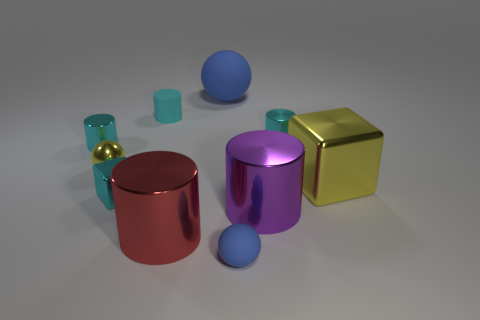There is a block that is to the left of the tiny rubber ball; is its color the same as the small shiny sphere?
Ensure brevity in your answer.  No. How many objects are either big objects or big shiny cylinders?
Provide a succinct answer. 4. Does the yellow metallic object that is right of the red cylinder have the same size as the tiny cyan matte cylinder?
Provide a short and direct response. No. What is the size of the cyan metallic object that is both behind the tiny yellow thing and right of the tiny yellow metallic sphere?
Your answer should be very brief. Small. How many other objects are the same shape as the large blue matte thing?
Offer a terse response. 2. What number of other objects are there of the same material as the big purple cylinder?
Give a very brief answer. 6. There is a red metallic thing that is the same shape as the small cyan rubber object; what is its size?
Offer a very short reply. Large. Do the big cube and the big rubber ball have the same color?
Your response must be concise. No. What is the color of the metallic thing that is both behind the large purple metal cylinder and in front of the large block?
Provide a short and direct response. Cyan. What number of objects are either blue rubber objects that are right of the big rubber thing or tiny cyan shiny cylinders?
Offer a very short reply. 3. 